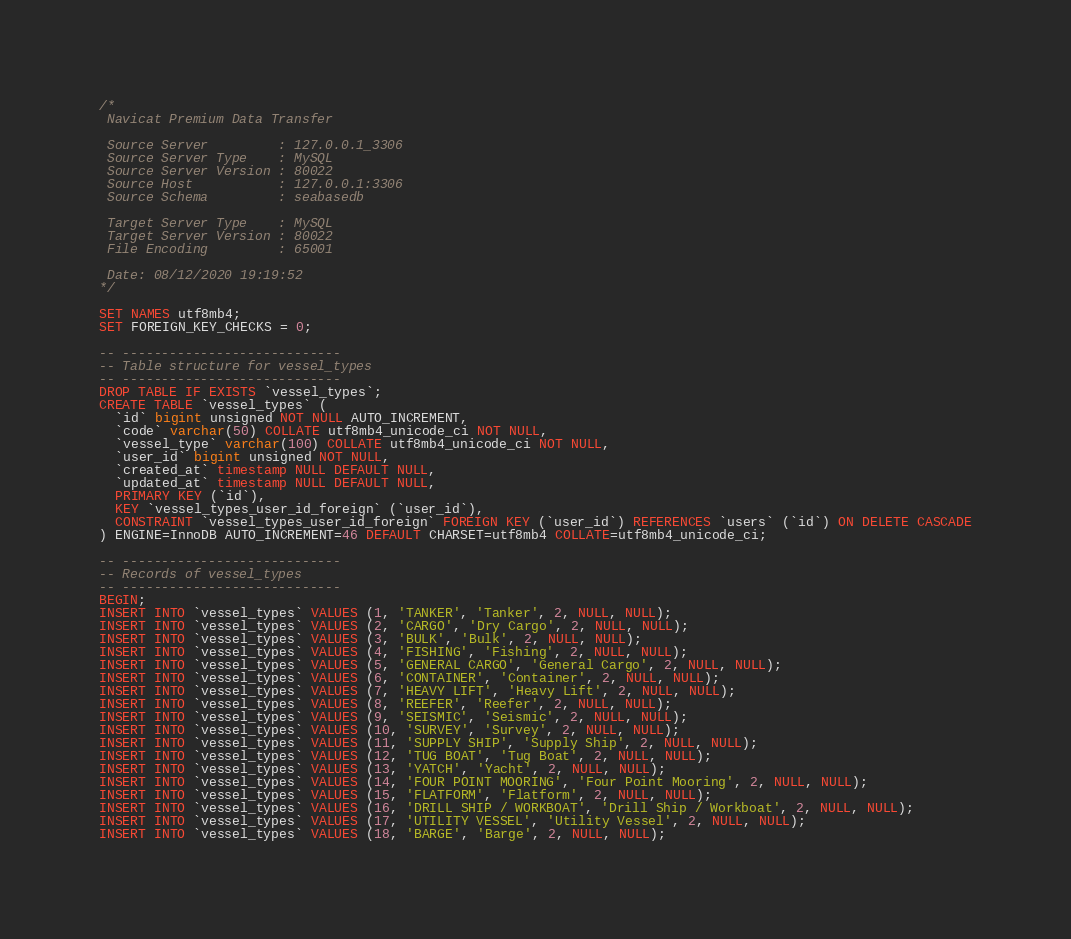Convert code to text. <code><loc_0><loc_0><loc_500><loc_500><_SQL_>/*
 Navicat Premium Data Transfer

 Source Server         : 127.0.0.1_3306
 Source Server Type    : MySQL
 Source Server Version : 80022
 Source Host           : 127.0.0.1:3306
 Source Schema         : seabasedb

 Target Server Type    : MySQL
 Target Server Version : 80022
 File Encoding         : 65001

 Date: 08/12/2020 19:19:52
*/

SET NAMES utf8mb4;
SET FOREIGN_KEY_CHECKS = 0;

-- ----------------------------
-- Table structure for vessel_types
-- ----------------------------
DROP TABLE IF EXISTS `vessel_types`;
CREATE TABLE `vessel_types` (
  `id` bigint unsigned NOT NULL AUTO_INCREMENT,
  `code` varchar(50) COLLATE utf8mb4_unicode_ci NOT NULL,
  `vessel_type` varchar(100) COLLATE utf8mb4_unicode_ci NOT NULL,
  `user_id` bigint unsigned NOT NULL,
  `created_at` timestamp NULL DEFAULT NULL,
  `updated_at` timestamp NULL DEFAULT NULL,
  PRIMARY KEY (`id`),
  KEY `vessel_types_user_id_foreign` (`user_id`),
  CONSTRAINT `vessel_types_user_id_foreign` FOREIGN KEY (`user_id`) REFERENCES `users` (`id`) ON DELETE CASCADE
) ENGINE=InnoDB AUTO_INCREMENT=46 DEFAULT CHARSET=utf8mb4 COLLATE=utf8mb4_unicode_ci;

-- ----------------------------
-- Records of vessel_types
-- ----------------------------
BEGIN;
INSERT INTO `vessel_types` VALUES (1, 'TANKER', 'Tanker', 2, NULL, NULL);
INSERT INTO `vessel_types` VALUES (2, 'CARGO', 'Dry Cargo', 2, NULL, NULL);
INSERT INTO `vessel_types` VALUES (3, 'BULK', 'Bulk', 2, NULL, NULL);
INSERT INTO `vessel_types` VALUES (4, 'FISHING', 'Fishing', 2, NULL, NULL);
INSERT INTO `vessel_types` VALUES (5, 'GENERAL CARGO', 'General Cargo', 2, NULL, NULL);
INSERT INTO `vessel_types` VALUES (6, 'CONTAINER', 'Container', 2, NULL, NULL);
INSERT INTO `vessel_types` VALUES (7, 'HEAVY LIFT', 'Heavy Lift', 2, NULL, NULL);
INSERT INTO `vessel_types` VALUES (8, 'REEFER', 'Reefer', 2, NULL, NULL);
INSERT INTO `vessel_types` VALUES (9, 'SEISMIC', 'Seismic', 2, NULL, NULL);
INSERT INTO `vessel_types` VALUES (10, 'SURVEY', 'Survey', 2, NULL, NULL);
INSERT INTO `vessel_types` VALUES (11, 'SUPPLY SHIP', 'Supply Ship', 2, NULL, NULL);
INSERT INTO `vessel_types` VALUES (12, 'TUG BOAT', 'Tug Boat', 2, NULL, NULL);
INSERT INTO `vessel_types` VALUES (13, 'YATCH', 'Yacht', 2, NULL, NULL);
INSERT INTO `vessel_types` VALUES (14, 'FOUR POINT MOORING', 'Four Point Mooring', 2, NULL, NULL);
INSERT INTO `vessel_types` VALUES (15, 'FLATFORM', 'Flatform', 2, NULL, NULL);
INSERT INTO `vessel_types` VALUES (16, 'DRILL SHIP / WORKBOAT', 'Drill Ship / Workboat', 2, NULL, NULL);
INSERT INTO `vessel_types` VALUES (17, 'UTILITY VESSEL', 'Utility Vessel', 2, NULL, NULL);
INSERT INTO `vessel_types` VALUES (18, 'BARGE', 'Barge', 2, NULL, NULL);</code> 